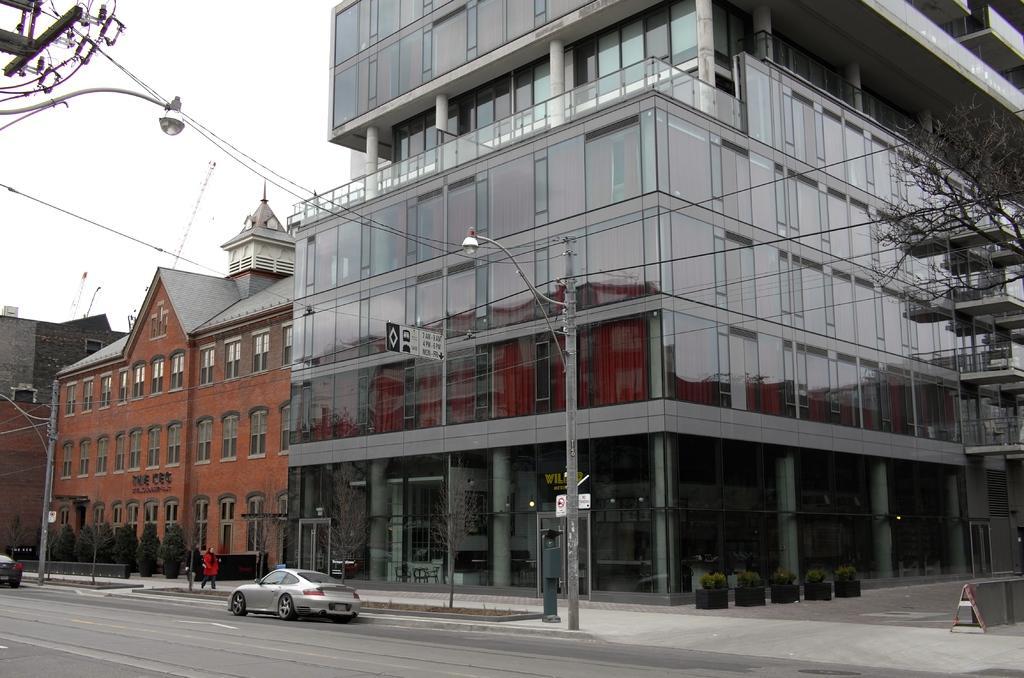Describe this image in one or two sentences. In this image we can see a few buildings, there are some plants, poles, lights, wires, persons, boards and vehicles on the road, also we can see a road divider. 